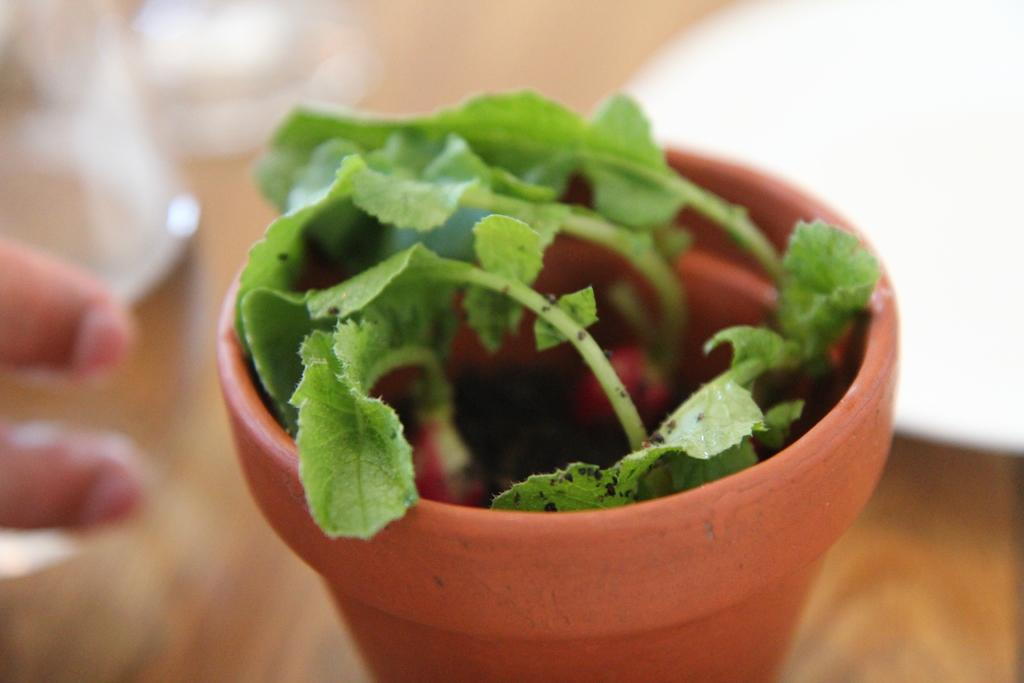What object can be seen in the image related to plants? There is a plant pot in the image. Can you describe any other elements in the image? The fingers of a person are visible beside the plant pot. What type of kite is being read by the person in the image? There is no kite or reading activity depicted in the image; it only shows a plant pot and the fingers of a person. 